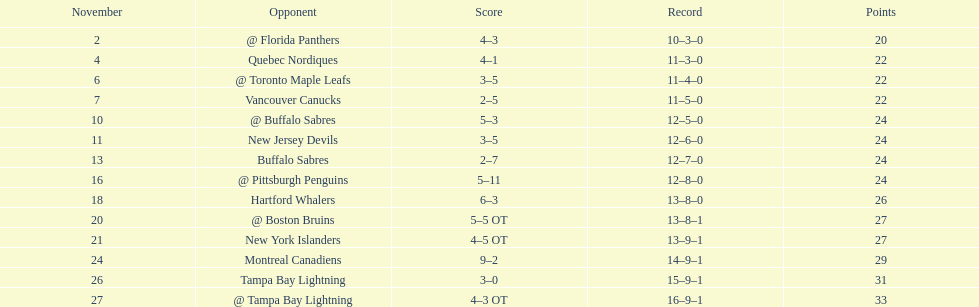Until the 1993-1994 season, how many successive seasons did the flyers fail to make the playoffs? 5. 